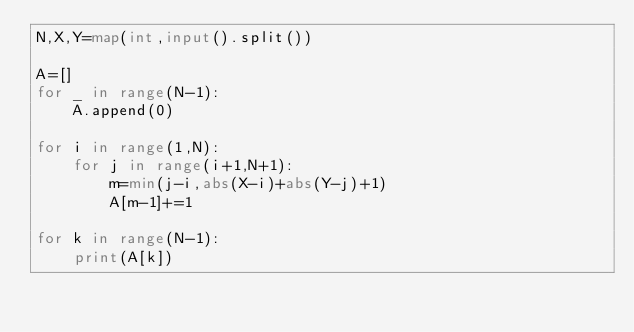Convert code to text. <code><loc_0><loc_0><loc_500><loc_500><_Python_>N,X,Y=map(int,input().split())

A=[]
for _ in range(N-1):
    A.append(0)  

for i in range(1,N):
    for j in range(i+1,N+1):
        m=min(j-i,abs(X-i)+abs(Y-j)+1)
        A[m-1]+=1

for k in range(N-1):
    print(A[k])


</code> 